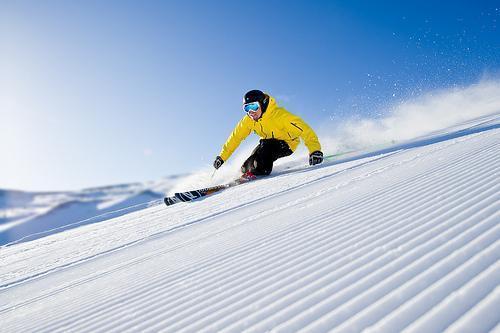How many people are in the photo?
Give a very brief answer. 1. 